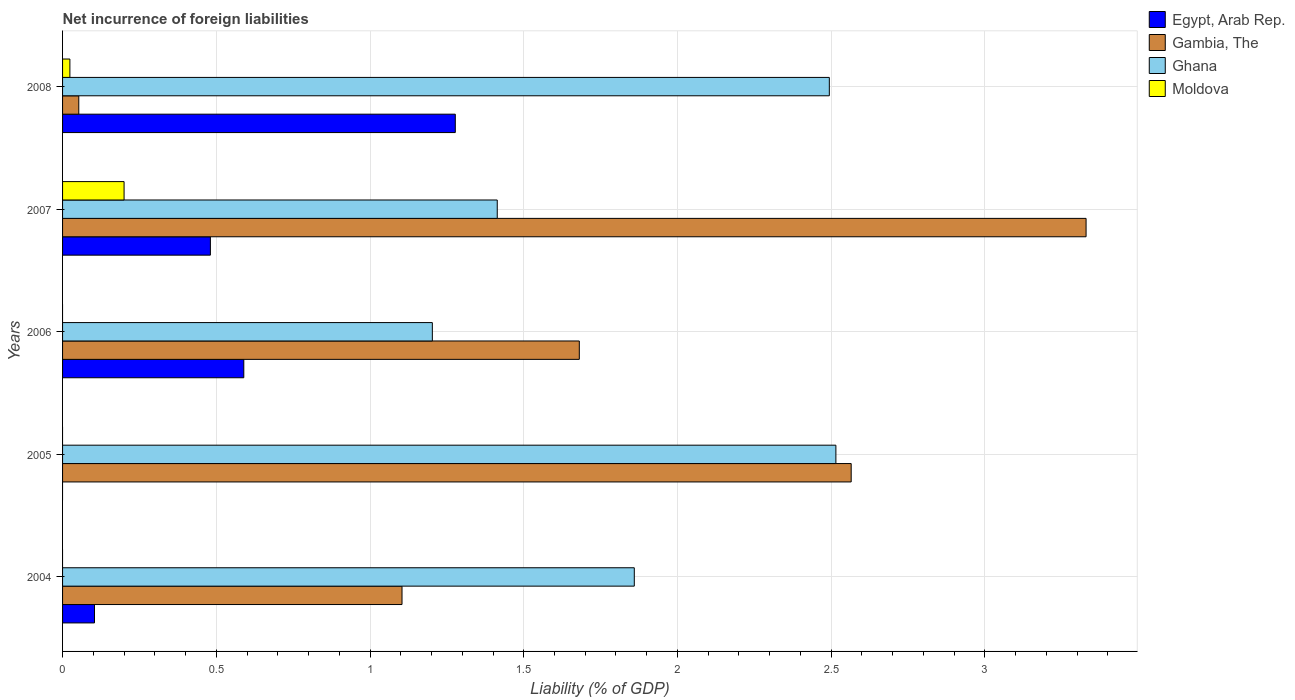How many groups of bars are there?
Offer a very short reply. 5. How many bars are there on the 3rd tick from the bottom?
Provide a short and direct response. 3. What is the net incurrence of foreign liabilities in Ghana in 2005?
Your response must be concise. 2.52. Across all years, what is the maximum net incurrence of foreign liabilities in Egypt, Arab Rep.?
Give a very brief answer. 1.28. In which year was the net incurrence of foreign liabilities in Gambia, The maximum?
Provide a succinct answer. 2007. What is the total net incurrence of foreign liabilities in Egypt, Arab Rep. in the graph?
Ensure brevity in your answer.  2.45. What is the difference between the net incurrence of foreign liabilities in Egypt, Arab Rep. in 2006 and that in 2008?
Your answer should be compact. -0.69. What is the difference between the net incurrence of foreign liabilities in Egypt, Arab Rep. in 2004 and the net incurrence of foreign liabilities in Gambia, The in 2006?
Offer a very short reply. -1.58. What is the average net incurrence of foreign liabilities in Egypt, Arab Rep. per year?
Keep it short and to the point. 0.49. In the year 2008, what is the difference between the net incurrence of foreign liabilities in Ghana and net incurrence of foreign liabilities in Moldova?
Your answer should be compact. 2.47. What is the ratio of the net incurrence of foreign liabilities in Egypt, Arab Rep. in 2007 to that in 2008?
Your answer should be compact. 0.38. What is the difference between the highest and the second highest net incurrence of foreign liabilities in Ghana?
Give a very brief answer. 0.02. What is the difference between the highest and the lowest net incurrence of foreign liabilities in Moldova?
Offer a very short reply. 0.2. In how many years, is the net incurrence of foreign liabilities in Gambia, The greater than the average net incurrence of foreign liabilities in Gambia, The taken over all years?
Provide a succinct answer. 2. Is the sum of the net incurrence of foreign liabilities in Ghana in 2005 and 2008 greater than the maximum net incurrence of foreign liabilities in Gambia, The across all years?
Provide a succinct answer. Yes. Is it the case that in every year, the sum of the net incurrence of foreign liabilities in Moldova and net incurrence of foreign liabilities in Gambia, The is greater than the sum of net incurrence of foreign liabilities in Ghana and net incurrence of foreign liabilities in Egypt, Arab Rep.?
Give a very brief answer. No. Is it the case that in every year, the sum of the net incurrence of foreign liabilities in Egypt, Arab Rep. and net incurrence of foreign liabilities in Gambia, The is greater than the net incurrence of foreign liabilities in Moldova?
Provide a short and direct response. Yes. Are all the bars in the graph horizontal?
Your answer should be very brief. Yes. How many years are there in the graph?
Provide a succinct answer. 5. Are the values on the major ticks of X-axis written in scientific E-notation?
Ensure brevity in your answer.  No. Does the graph contain grids?
Your response must be concise. Yes. Where does the legend appear in the graph?
Your response must be concise. Top right. What is the title of the graph?
Your answer should be very brief. Net incurrence of foreign liabilities. What is the label or title of the X-axis?
Offer a terse response. Liability (% of GDP). What is the Liability (% of GDP) of Egypt, Arab Rep. in 2004?
Your response must be concise. 0.1. What is the Liability (% of GDP) of Gambia, The in 2004?
Your answer should be very brief. 1.1. What is the Liability (% of GDP) of Ghana in 2004?
Keep it short and to the point. 1.86. What is the Liability (% of GDP) in Egypt, Arab Rep. in 2005?
Make the answer very short. 0. What is the Liability (% of GDP) in Gambia, The in 2005?
Your answer should be very brief. 2.57. What is the Liability (% of GDP) of Ghana in 2005?
Offer a very short reply. 2.52. What is the Liability (% of GDP) in Egypt, Arab Rep. in 2006?
Give a very brief answer. 0.59. What is the Liability (% of GDP) of Gambia, The in 2006?
Offer a very short reply. 1.68. What is the Liability (% of GDP) in Ghana in 2006?
Provide a short and direct response. 1.2. What is the Liability (% of GDP) in Egypt, Arab Rep. in 2007?
Your answer should be very brief. 0.48. What is the Liability (% of GDP) of Gambia, The in 2007?
Your answer should be compact. 3.33. What is the Liability (% of GDP) in Ghana in 2007?
Your answer should be very brief. 1.41. What is the Liability (% of GDP) of Moldova in 2007?
Your answer should be very brief. 0.2. What is the Liability (% of GDP) of Egypt, Arab Rep. in 2008?
Ensure brevity in your answer.  1.28. What is the Liability (% of GDP) of Gambia, The in 2008?
Your answer should be very brief. 0.05. What is the Liability (% of GDP) of Ghana in 2008?
Your response must be concise. 2.49. What is the Liability (% of GDP) in Moldova in 2008?
Offer a terse response. 0.02. Across all years, what is the maximum Liability (% of GDP) in Egypt, Arab Rep.?
Keep it short and to the point. 1.28. Across all years, what is the maximum Liability (% of GDP) in Gambia, The?
Make the answer very short. 3.33. Across all years, what is the maximum Liability (% of GDP) in Ghana?
Make the answer very short. 2.52. Across all years, what is the maximum Liability (% of GDP) of Moldova?
Offer a terse response. 0.2. Across all years, what is the minimum Liability (% of GDP) in Egypt, Arab Rep.?
Provide a short and direct response. 0. Across all years, what is the minimum Liability (% of GDP) in Gambia, The?
Provide a short and direct response. 0.05. Across all years, what is the minimum Liability (% of GDP) of Ghana?
Offer a terse response. 1.2. Across all years, what is the minimum Liability (% of GDP) of Moldova?
Make the answer very short. 0. What is the total Liability (% of GDP) of Egypt, Arab Rep. in the graph?
Provide a short and direct response. 2.45. What is the total Liability (% of GDP) in Gambia, The in the graph?
Make the answer very short. 8.73. What is the total Liability (% of GDP) of Ghana in the graph?
Offer a very short reply. 9.49. What is the total Liability (% of GDP) in Moldova in the graph?
Offer a terse response. 0.22. What is the difference between the Liability (% of GDP) of Gambia, The in 2004 and that in 2005?
Offer a very short reply. -1.46. What is the difference between the Liability (% of GDP) in Ghana in 2004 and that in 2005?
Provide a succinct answer. -0.66. What is the difference between the Liability (% of GDP) in Egypt, Arab Rep. in 2004 and that in 2006?
Give a very brief answer. -0.49. What is the difference between the Liability (% of GDP) of Gambia, The in 2004 and that in 2006?
Give a very brief answer. -0.58. What is the difference between the Liability (% of GDP) of Ghana in 2004 and that in 2006?
Your answer should be compact. 0.66. What is the difference between the Liability (% of GDP) in Egypt, Arab Rep. in 2004 and that in 2007?
Keep it short and to the point. -0.38. What is the difference between the Liability (% of GDP) of Gambia, The in 2004 and that in 2007?
Your answer should be very brief. -2.23. What is the difference between the Liability (% of GDP) of Ghana in 2004 and that in 2007?
Provide a succinct answer. 0.45. What is the difference between the Liability (% of GDP) of Egypt, Arab Rep. in 2004 and that in 2008?
Keep it short and to the point. -1.17. What is the difference between the Liability (% of GDP) of Gambia, The in 2004 and that in 2008?
Provide a succinct answer. 1.05. What is the difference between the Liability (% of GDP) in Ghana in 2004 and that in 2008?
Provide a succinct answer. -0.63. What is the difference between the Liability (% of GDP) in Gambia, The in 2005 and that in 2006?
Your response must be concise. 0.88. What is the difference between the Liability (% of GDP) in Ghana in 2005 and that in 2006?
Your response must be concise. 1.31. What is the difference between the Liability (% of GDP) in Gambia, The in 2005 and that in 2007?
Provide a succinct answer. -0.76. What is the difference between the Liability (% of GDP) of Ghana in 2005 and that in 2007?
Offer a very short reply. 1.1. What is the difference between the Liability (% of GDP) of Gambia, The in 2005 and that in 2008?
Give a very brief answer. 2.51. What is the difference between the Liability (% of GDP) in Ghana in 2005 and that in 2008?
Provide a short and direct response. 0.02. What is the difference between the Liability (% of GDP) of Egypt, Arab Rep. in 2006 and that in 2007?
Your answer should be compact. 0.11. What is the difference between the Liability (% of GDP) in Gambia, The in 2006 and that in 2007?
Keep it short and to the point. -1.65. What is the difference between the Liability (% of GDP) of Ghana in 2006 and that in 2007?
Your response must be concise. -0.21. What is the difference between the Liability (% of GDP) of Egypt, Arab Rep. in 2006 and that in 2008?
Give a very brief answer. -0.69. What is the difference between the Liability (% of GDP) of Gambia, The in 2006 and that in 2008?
Give a very brief answer. 1.63. What is the difference between the Liability (% of GDP) in Ghana in 2006 and that in 2008?
Offer a very short reply. -1.29. What is the difference between the Liability (% of GDP) in Egypt, Arab Rep. in 2007 and that in 2008?
Your answer should be compact. -0.8. What is the difference between the Liability (% of GDP) in Gambia, The in 2007 and that in 2008?
Offer a terse response. 3.28. What is the difference between the Liability (% of GDP) of Ghana in 2007 and that in 2008?
Offer a very short reply. -1.08. What is the difference between the Liability (% of GDP) of Moldova in 2007 and that in 2008?
Make the answer very short. 0.18. What is the difference between the Liability (% of GDP) of Egypt, Arab Rep. in 2004 and the Liability (% of GDP) of Gambia, The in 2005?
Give a very brief answer. -2.46. What is the difference between the Liability (% of GDP) of Egypt, Arab Rep. in 2004 and the Liability (% of GDP) of Ghana in 2005?
Ensure brevity in your answer.  -2.41. What is the difference between the Liability (% of GDP) in Gambia, The in 2004 and the Liability (% of GDP) in Ghana in 2005?
Your answer should be compact. -1.41. What is the difference between the Liability (% of GDP) of Egypt, Arab Rep. in 2004 and the Liability (% of GDP) of Gambia, The in 2006?
Your answer should be compact. -1.58. What is the difference between the Liability (% of GDP) in Egypt, Arab Rep. in 2004 and the Liability (% of GDP) in Ghana in 2006?
Offer a very short reply. -1.1. What is the difference between the Liability (% of GDP) of Gambia, The in 2004 and the Liability (% of GDP) of Ghana in 2006?
Your answer should be very brief. -0.1. What is the difference between the Liability (% of GDP) of Egypt, Arab Rep. in 2004 and the Liability (% of GDP) of Gambia, The in 2007?
Offer a terse response. -3.23. What is the difference between the Liability (% of GDP) of Egypt, Arab Rep. in 2004 and the Liability (% of GDP) of Ghana in 2007?
Offer a very short reply. -1.31. What is the difference between the Liability (% of GDP) in Egypt, Arab Rep. in 2004 and the Liability (% of GDP) in Moldova in 2007?
Your response must be concise. -0.1. What is the difference between the Liability (% of GDP) of Gambia, The in 2004 and the Liability (% of GDP) of Ghana in 2007?
Your answer should be compact. -0.31. What is the difference between the Liability (% of GDP) of Gambia, The in 2004 and the Liability (% of GDP) of Moldova in 2007?
Your answer should be compact. 0.9. What is the difference between the Liability (% of GDP) of Ghana in 2004 and the Liability (% of GDP) of Moldova in 2007?
Keep it short and to the point. 1.66. What is the difference between the Liability (% of GDP) in Egypt, Arab Rep. in 2004 and the Liability (% of GDP) in Gambia, The in 2008?
Give a very brief answer. 0.05. What is the difference between the Liability (% of GDP) in Egypt, Arab Rep. in 2004 and the Liability (% of GDP) in Ghana in 2008?
Your response must be concise. -2.39. What is the difference between the Liability (% of GDP) of Egypt, Arab Rep. in 2004 and the Liability (% of GDP) of Moldova in 2008?
Your answer should be compact. 0.08. What is the difference between the Liability (% of GDP) in Gambia, The in 2004 and the Liability (% of GDP) in Ghana in 2008?
Ensure brevity in your answer.  -1.39. What is the difference between the Liability (% of GDP) of Gambia, The in 2004 and the Liability (% of GDP) of Moldova in 2008?
Make the answer very short. 1.08. What is the difference between the Liability (% of GDP) in Ghana in 2004 and the Liability (% of GDP) in Moldova in 2008?
Provide a short and direct response. 1.84. What is the difference between the Liability (% of GDP) in Gambia, The in 2005 and the Liability (% of GDP) in Ghana in 2006?
Your answer should be very brief. 1.36. What is the difference between the Liability (% of GDP) of Gambia, The in 2005 and the Liability (% of GDP) of Ghana in 2007?
Provide a succinct answer. 1.15. What is the difference between the Liability (% of GDP) of Gambia, The in 2005 and the Liability (% of GDP) of Moldova in 2007?
Offer a very short reply. 2.37. What is the difference between the Liability (% of GDP) in Ghana in 2005 and the Liability (% of GDP) in Moldova in 2007?
Offer a terse response. 2.32. What is the difference between the Liability (% of GDP) in Gambia, The in 2005 and the Liability (% of GDP) in Ghana in 2008?
Offer a very short reply. 0.07. What is the difference between the Liability (% of GDP) in Gambia, The in 2005 and the Liability (% of GDP) in Moldova in 2008?
Your response must be concise. 2.54. What is the difference between the Liability (% of GDP) of Ghana in 2005 and the Liability (% of GDP) of Moldova in 2008?
Provide a short and direct response. 2.49. What is the difference between the Liability (% of GDP) of Egypt, Arab Rep. in 2006 and the Liability (% of GDP) of Gambia, The in 2007?
Your answer should be compact. -2.74. What is the difference between the Liability (% of GDP) in Egypt, Arab Rep. in 2006 and the Liability (% of GDP) in Ghana in 2007?
Offer a terse response. -0.82. What is the difference between the Liability (% of GDP) in Egypt, Arab Rep. in 2006 and the Liability (% of GDP) in Moldova in 2007?
Provide a succinct answer. 0.39. What is the difference between the Liability (% of GDP) of Gambia, The in 2006 and the Liability (% of GDP) of Ghana in 2007?
Keep it short and to the point. 0.27. What is the difference between the Liability (% of GDP) of Gambia, The in 2006 and the Liability (% of GDP) of Moldova in 2007?
Keep it short and to the point. 1.48. What is the difference between the Liability (% of GDP) of Egypt, Arab Rep. in 2006 and the Liability (% of GDP) of Gambia, The in 2008?
Provide a succinct answer. 0.54. What is the difference between the Liability (% of GDP) of Egypt, Arab Rep. in 2006 and the Liability (% of GDP) of Ghana in 2008?
Your response must be concise. -1.9. What is the difference between the Liability (% of GDP) in Egypt, Arab Rep. in 2006 and the Liability (% of GDP) in Moldova in 2008?
Provide a short and direct response. 0.57. What is the difference between the Liability (% of GDP) in Gambia, The in 2006 and the Liability (% of GDP) in Ghana in 2008?
Ensure brevity in your answer.  -0.81. What is the difference between the Liability (% of GDP) of Gambia, The in 2006 and the Liability (% of GDP) of Moldova in 2008?
Make the answer very short. 1.66. What is the difference between the Liability (% of GDP) of Ghana in 2006 and the Liability (% of GDP) of Moldova in 2008?
Your answer should be compact. 1.18. What is the difference between the Liability (% of GDP) of Egypt, Arab Rep. in 2007 and the Liability (% of GDP) of Gambia, The in 2008?
Your response must be concise. 0.43. What is the difference between the Liability (% of GDP) in Egypt, Arab Rep. in 2007 and the Liability (% of GDP) in Ghana in 2008?
Give a very brief answer. -2.01. What is the difference between the Liability (% of GDP) in Egypt, Arab Rep. in 2007 and the Liability (% of GDP) in Moldova in 2008?
Make the answer very short. 0.46. What is the difference between the Liability (% of GDP) in Gambia, The in 2007 and the Liability (% of GDP) in Ghana in 2008?
Your answer should be compact. 0.84. What is the difference between the Liability (% of GDP) of Gambia, The in 2007 and the Liability (% of GDP) of Moldova in 2008?
Offer a very short reply. 3.31. What is the difference between the Liability (% of GDP) in Ghana in 2007 and the Liability (% of GDP) in Moldova in 2008?
Make the answer very short. 1.39. What is the average Liability (% of GDP) of Egypt, Arab Rep. per year?
Offer a very short reply. 0.49. What is the average Liability (% of GDP) of Gambia, The per year?
Your response must be concise. 1.75. What is the average Liability (% of GDP) of Ghana per year?
Provide a short and direct response. 1.9. What is the average Liability (% of GDP) in Moldova per year?
Offer a terse response. 0.04. In the year 2004, what is the difference between the Liability (% of GDP) in Egypt, Arab Rep. and Liability (% of GDP) in Gambia, The?
Keep it short and to the point. -1. In the year 2004, what is the difference between the Liability (% of GDP) in Egypt, Arab Rep. and Liability (% of GDP) in Ghana?
Ensure brevity in your answer.  -1.76. In the year 2004, what is the difference between the Liability (% of GDP) of Gambia, The and Liability (% of GDP) of Ghana?
Provide a short and direct response. -0.76. In the year 2005, what is the difference between the Liability (% of GDP) in Gambia, The and Liability (% of GDP) in Ghana?
Ensure brevity in your answer.  0.05. In the year 2006, what is the difference between the Liability (% of GDP) of Egypt, Arab Rep. and Liability (% of GDP) of Gambia, The?
Your response must be concise. -1.09. In the year 2006, what is the difference between the Liability (% of GDP) of Egypt, Arab Rep. and Liability (% of GDP) of Ghana?
Your answer should be very brief. -0.61. In the year 2006, what is the difference between the Liability (% of GDP) in Gambia, The and Liability (% of GDP) in Ghana?
Provide a short and direct response. 0.48. In the year 2007, what is the difference between the Liability (% of GDP) in Egypt, Arab Rep. and Liability (% of GDP) in Gambia, The?
Your answer should be very brief. -2.85. In the year 2007, what is the difference between the Liability (% of GDP) of Egypt, Arab Rep. and Liability (% of GDP) of Ghana?
Ensure brevity in your answer.  -0.93. In the year 2007, what is the difference between the Liability (% of GDP) of Egypt, Arab Rep. and Liability (% of GDP) of Moldova?
Your answer should be very brief. 0.28. In the year 2007, what is the difference between the Liability (% of GDP) of Gambia, The and Liability (% of GDP) of Ghana?
Offer a very short reply. 1.92. In the year 2007, what is the difference between the Liability (% of GDP) of Gambia, The and Liability (% of GDP) of Moldova?
Keep it short and to the point. 3.13. In the year 2007, what is the difference between the Liability (% of GDP) of Ghana and Liability (% of GDP) of Moldova?
Keep it short and to the point. 1.21. In the year 2008, what is the difference between the Liability (% of GDP) in Egypt, Arab Rep. and Liability (% of GDP) in Gambia, The?
Offer a very short reply. 1.22. In the year 2008, what is the difference between the Liability (% of GDP) in Egypt, Arab Rep. and Liability (% of GDP) in Ghana?
Your response must be concise. -1.22. In the year 2008, what is the difference between the Liability (% of GDP) of Egypt, Arab Rep. and Liability (% of GDP) of Moldova?
Offer a terse response. 1.25. In the year 2008, what is the difference between the Liability (% of GDP) in Gambia, The and Liability (% of GDP) in Ghana?
Give a very brief answer. -2.44. In the year 2008, what is the difference between the Liability (% of GDP) of Gambia, The and Liability (% of GDP) of Moldova?
Offer a terse response. 0.03. In the year 2008, what is the difference between the Liability (% of GDP) in Ghana and Liability (% of GDP) in Moldova?
Your response must be concise. 2.47. What is the ratio of the Liability (% of GDP) of Gambia, The in 2004 to that in 2005?
Provide a succinct answer. 0.43. What is the ratio of the Liability (% of GDP) in Ghana in 2004 to that in 2005?
Make the answer very short. 0.74. What is the ratio of the Liability (% of GDP) of Egypt, Arab Rep. in 2004 to that in 2006?
Offer a terse response. 0.18. What is the ratio of the Liability (% of GDP) in Gambia, The in 2004 to that in 2006?
Provide a short and direct response. 0.66. What is the ratio of the Liability (% of GDP) in Ghana in 2004 to that in 2006?
Keep it short and to the point. 1.55. What is the ratio of the Liability (% of GDP) in Egypt, Arab Rep. in 2004 to that in 2007?
Ensure brevity in your answer.  0.22. What is the ratio of the Liability (% of GDP) of Gambia, The in 2004 to that in 2007?
Provide a succinct answer. 0.33. What is the ratio of the Liability (% of GDP) of Ghana in 2004 to that in 2007?
Give a very brief answer. 1.32. What is the ratio of the Liability (% of GDP) of Egypt, Arab Rep. in 2004 to that in 2008?
Keep it short and to the point. 0.08. What is the ratio of the Liability (% of GDP) in Gambia, The in 2004 to that in 2008?
Give a very brief answer. 20.94. What is the ratio of the Liability (% of GDP) of Ghana in 2004 to that in 2008?
Make the answer very short. 0.75. What is the ratio of the Liability (% of GDP) in Gambia, The in 2005 to that in 2006?
Provide a succinct answer. 1.53. What is the ratio of the Liability (% of GDP) in Ghana in 2005 to that in 2006?
Provide a succinct answer. 2.09. What is the ratio of the Liability (% of GDP) of Gambia, The in 2005 to that in 2007?
Give a very brief answer. 0.77. What is the ratio of the Liability (% of GDP) of Ghana in 2005 to that in 2007?
Offer a terse response. 1.78. What is the ratio of the Liability (% of GDP) of Gambia, The in 2005 to that in 2008?
Provide a short and direct response. 48.65. What is the ratio of the Liability (% of GDP) of Ghana in 2005 to that in 2008?
Offer a terse response. 1.01. What is the ratio of the Liability (% of GDP) of Egypt, Arab Rep. in 2006 to that in 2007?
Ensure brevity in your answer.  1.23. What is the ratio of the Liability (% of GDP) of Gambia, The in 2006 to that in 2007?
Provide a short and direct response. 0.5. What is the ratio of the Liability (% of GDP) of Ghana in 2006 to that in 2007?
Make the answer very short. 0.85. What is the ratio of the Liability (% of GDP) of Egypt, Arab Rep. in 2006 to that in 2008?
Offer a very short reply. 0.46. What is the ratio of the Liability (% of GDP) of Gambia, The in 2006 to that in 2008?
Your answer should be compact. 31.88. What is the ratio of the Liability (% of GDP) in Ghana in 2006 to that in 2008?
Your answer should be very brief. 0.48. What is the ratio of the Liability (% of GDP) of Egypt, Arab Rep. in 2007 to that in 2008?
Make the answer very short. 0.38. What is the ratio of the Liability (% of GDP) in Gambia, The in 2007 to that in 2008?
Make the answer very short. 63.14. What is the ratio of the Liability (% of GDP) of Ghana in 2007 to that in 2008?
Offer a terse response. 0.57. What is the ratio of the Liability (% of GDP) in Moldova in 2007 to that in 2008?
Provide a short and direct response. 8.39. What is the difference between the highest and the second highest Liability (% of GDP) of Egypt, Arab Rep.?
Provide a short and direct response. 0.69. What is the difference between the highest and the second highest Liability (% of GDP) of Gambia, The?
Your answer should be very brief. 0.76. What is the difference between the highest and the second highest Liability (% of GDP) in Ghana?
Ensure brevity in your answer.  0.02. What is the difference between the highest and the lowest Liability (% of GDP) in Egypt, Arab Rep.?
Your answer should be compact. 1.28. What is the difference between the highest and the lowest Liability (% of GDP) in Gambia, The?
Make the answer very short. 3.28. What is the difference between the highest and the lowest Liability (% of GDP) of Ghana?
Keep it short and to the point. 1.31. What is the difference between the highest and the lowest Liability (% of GDP) of Moldova?
Your answer should be compact. 0.2. 